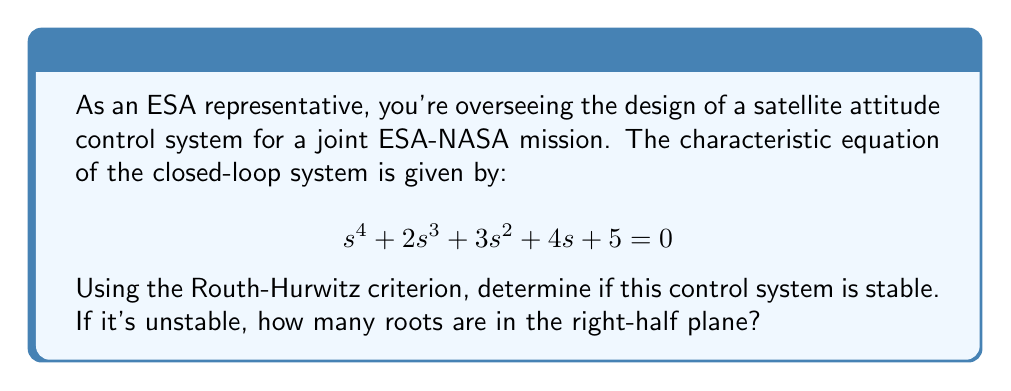Give your solution to this math problem. To apply the Routh-Hurwitz criterion:

1) First, create the Routh array:

   $$\begin{array}{c|c c}
   s^4 & 1 & 3 & 5 \\
   s^3 & 2 & 4 & 0 \\
   s^2 & b_1 & b_2 & \\
   s^1 & c_1 & & \\
   s^0 & d_1 & &
   \end{array}$$

2) Calculate $b_1$:
   $$b_1 = \frac{(2)(3) - (1)(4)}{2} = \frac{6-4}{2} = 1$$

3) Calculate $b_2$:
   $$b_2 = \frac{(2)(5) - (1)(0)}{2} = 5$$

4) Calculate $c_1$:
   $$c_1 = \frac{(1)(4) - (2)(5)}{1} = 4 - 10 = -6$$

5) Calculate $d_1$:
   $$d_1 = 5$$

6) The complete Routh array:

   $$\begin{array}{c|c c}
   s^4 & 1 & 3 & 5 \\
   s^3 & 2 & 4 & 0 \\
   s^2 & 1 & 5 & \\
   s^1 & -6 & & \\
   s^0 & 5 & &
   \end{array}$$

7) Analyze the first column:
   There is one sign change (from -6 to 5) in the first column.

8) Conclusion:
   The number of sign changes in the first column of the Routh array indicates the number of roots in the right-half plane. With one sign change, the system has one root in the right-half plane, making it unstable.
Answer: Unstable; 1 root in right-half plane 